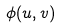<formula> <loc_0><loc_0><loc_500><loc_500>\phi ( u , v )</formula> 